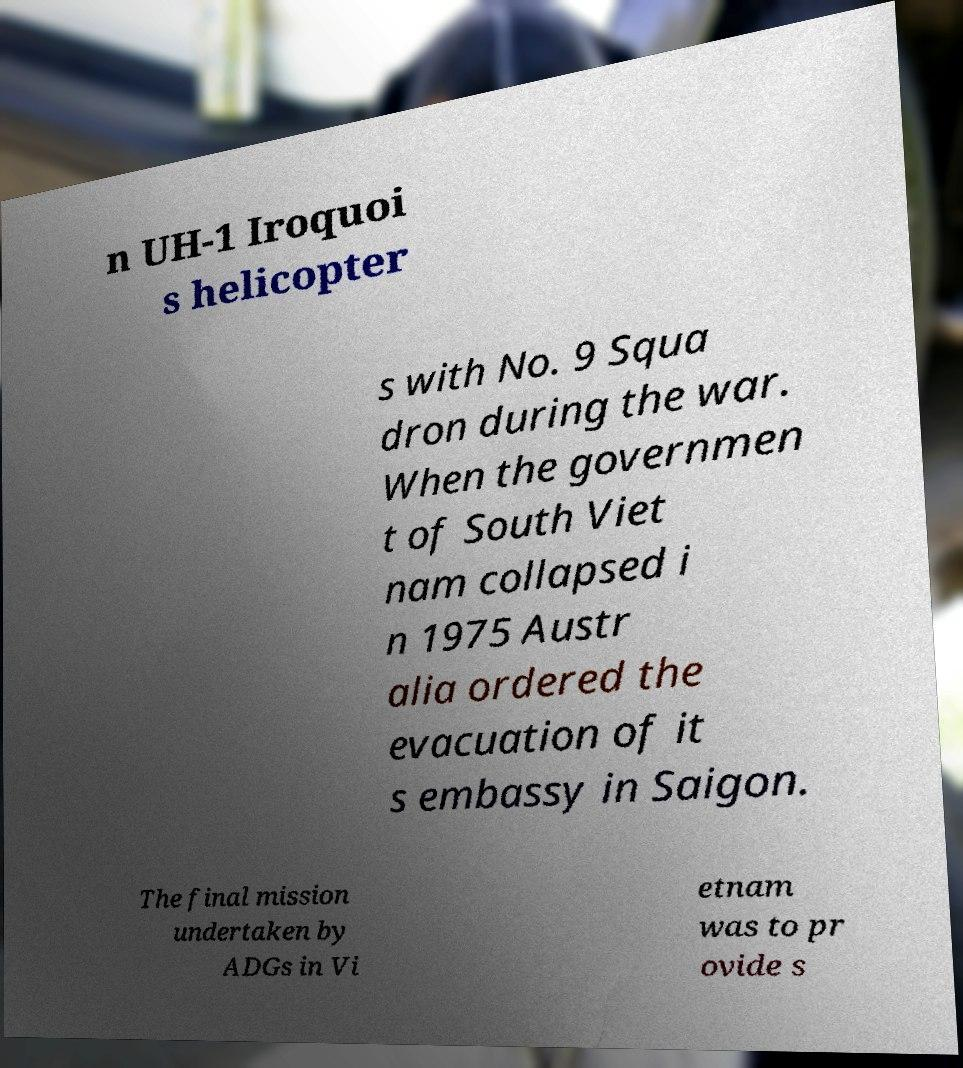Can you accurately transcribe the text from the provided image for me? n UH-1 Iroquoi s helicopter s with No. 9 Squa dron during the war. When the governmen t of South Viet nam collapsed i n 1975 Austr alia ordered the evacuation of it s embassy in Saigon. The final mission undertaken by ADGs in Vi etnam was to pr ovide s 